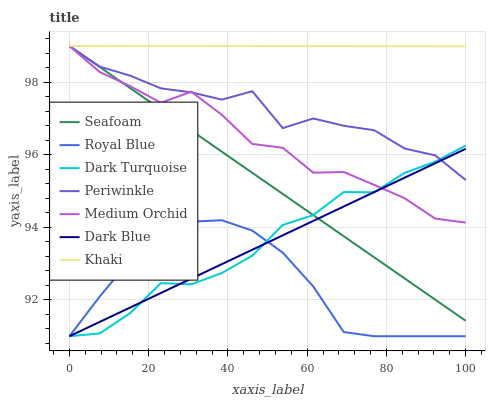Does Royal Blue have the minimum area under the curve?
Answer yes or no. Yes. Does Khaki have the maximum area under the curve?
Answer yes or no. Yes. Does Dark Blue have the minimum area under the curve?
Answer yes or no. No. Does Dark Blue have the maximum area under the curve?
Answer yes or no. No. Is Dark Blue the smoothest?
Answer yes or no. Yes. Is Periwinkle the roughest?
Answer yes or no. Yes. Is Dark Turquoise the smoothest?
Answer yes or no. No. Is Dark Turquoise the roughest?
Answer yes or no. No. Does Dark Blue have the lowest value?
Answer yes or no. Yes. Does Medium Orchid have the lowest value?
Answer yes or no. No. Does Periwinkle have the highest value?
Answer yes or no. Yes. Does Dark Blue have the highest value?
Answer yes or no. No. Is Royal Blue less than Khaki?
Answer yes or no. Yes. Is Khaki greater than Dark Turquoise?
Answer yes or no. Yes. Does Seafoam intersect Dark Turquoise?
Answer yes or no. Yes. Is Seafoam less than Dark Turquoise?
Answer yes or no. No. Is Seafoam greater than Dark Turquoise?
Answer yes or no. No. Does Royal Blue intersect Khaki?
Answer yes or no. No. 